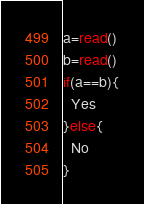Convert code to text. <code><loc_0><loc_0><loc_500><loc_500><_bc_>a=read()
b=read()
if(a==b){
  Yes
}else{
  No
}</code> 